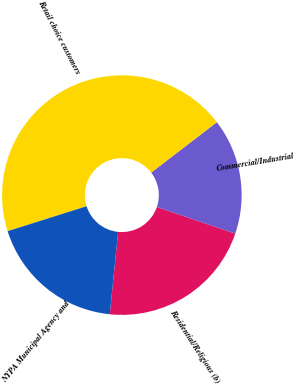Convert chart. <chart><loc_0><loc_0><loc_500><loc_500><pie_chart><fcel>Residential/Religious (b)<fcel>Commercial/Industrial<fcel>Retail choice customers<fcel>NYPA Municipal Agency and<nl><fcel>21.4%<fcel>15.63%<fcel>44.45%<fcel>18.52%<nl></chart> 